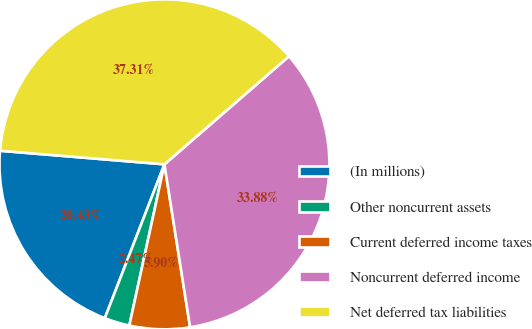Convert chart. <chart><loc_0><loc_0><loc_500><loc_500><pie_chart><fcel>(In millions)<fcel>Other noncurrent assets<fcel>Current deferred income taxes<fcel>Noncurrent deferred income<fcel>Net deferred tax liabilities<nl><fcel>20.43%<fcel>2.47%<fcel>5.9%<fcel>33.88%<fcel>37.31%<nl></chart> 